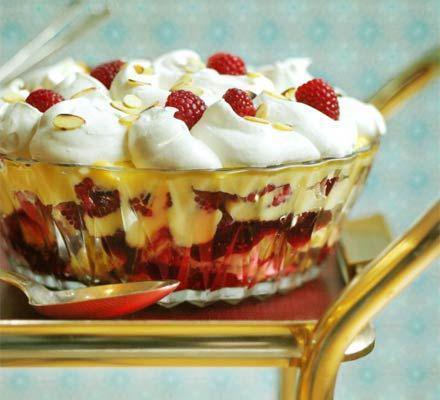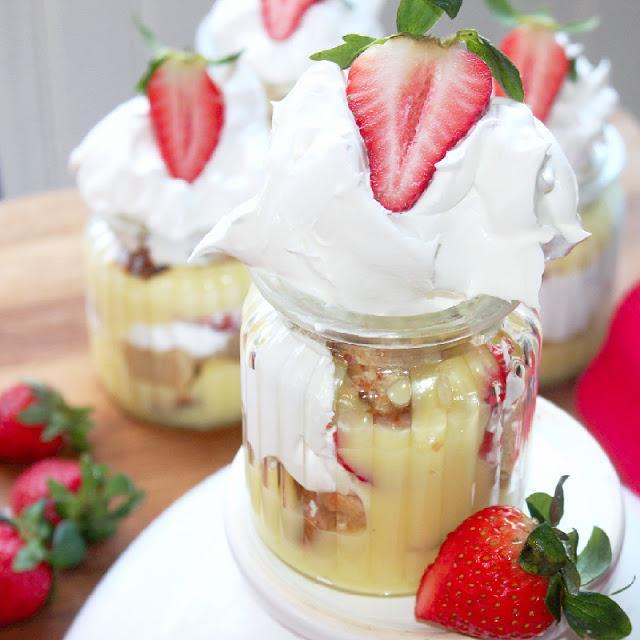The first image is the image on the left, the second image is the image on the right. For the images shown, is this caption "One image shows a single large trifle dessert in a footed serving bowl." true? Answer yes or no. No. 